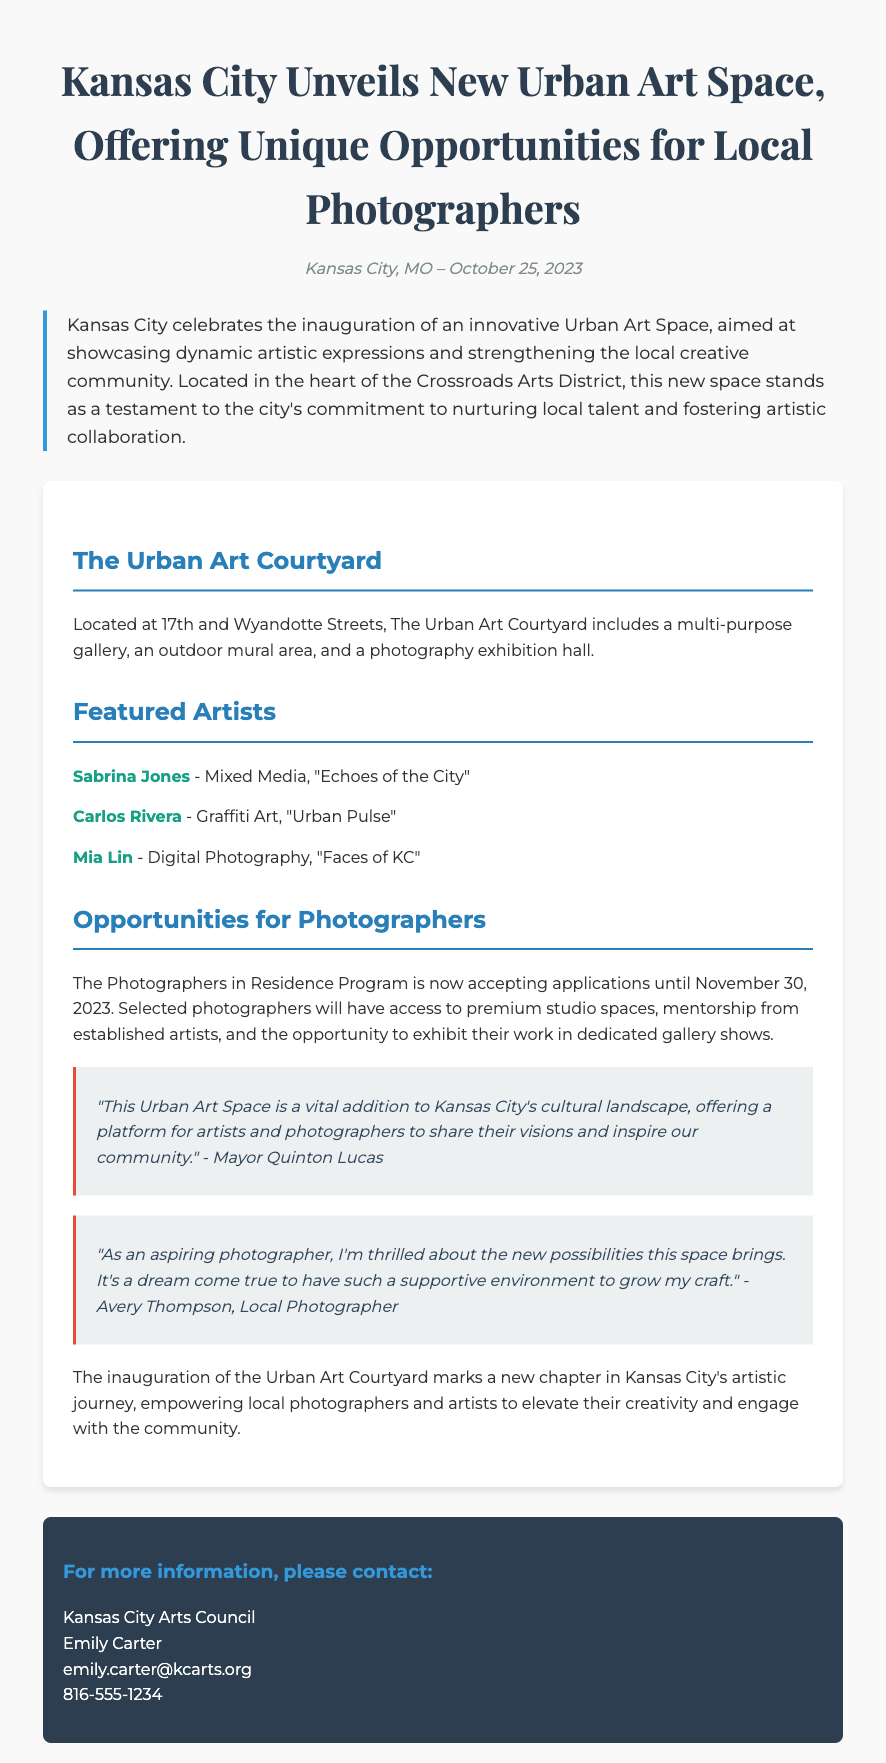What is the name of the new urban art space? The document refers to the new urban art space as "The Urban Art Courtyard."
Answer: The Urban Art Courtyard Where is the Urban Art Courtyard located? The document specifies the address of the Urban Art Courtyard as "17th and Wyandotte Streets."
Answer: 17th and Wyandotte Streets What is the deadline for the Photographers in Residence Program applications? The document states that applications for the program are accepted until "November 30, 2023."
Answer: November 30, 2023 Who made the quote about the Urban Art Space being a vital addition? The quote is attributed to "Mayor Quinton Lucas."
Answer: Mayor Quinton Lucas What type of art does Mia Lin represent in the featured artists section? The document identifies Mia Lin as a digital photographer focusing on the piece "Faces of KC."
Answer: Digital Photography What opportunities will selected photographers receive? The document mentions that selected photographers will have access to "premium studio spaces, mentorship from established artists, and the opportunity to exhibit their work."
Answer: Premium studio spaces, mentorship from established artists, and exhibit opportunities What does the new urban art space aim to strengthen in the community? According to the document, the space aims to strengthen "the local creative community."
Answer: The local creative community How is the Urban Art Space described in the introduction? The introduction refers to the Urban Art Space as "innovative" and a testament to the city's commitment.
Answer: Innovative 